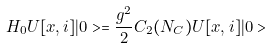Convert formula to latex. <formula><loc_0><loc_0><loc_500><loc_500>H _ { 0 } U [ x , i ] | 0 > = \frac { g ^ { 2 } } { 2 } C _ { 2 } ( N _ { C } ) U [ x , i ] | 0 ></formula> 